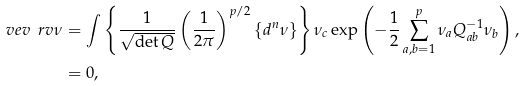Convert formula to latex. <formula><loc_0><loc_0><loc_500><loc_500>\ v e v { \ r v { \nu } } & = \int \left \{ \frac { 1 } { \sqrt { \det Q } } \left ( \frac { 1 } { 2 \pi } \right ) ^ { p / 2 } \left \{ d ^ { n } \nu \right \} \right \} \nu _ { c } \exp \left ( - \frac { 1 } { 2 } \sum _ { a , b = 1 } ^ { p } \nu _ { a } Q _ { a b } ^ { - 1 } \nu _ { b } \right ) , \\ & = 0 ,</formula> 